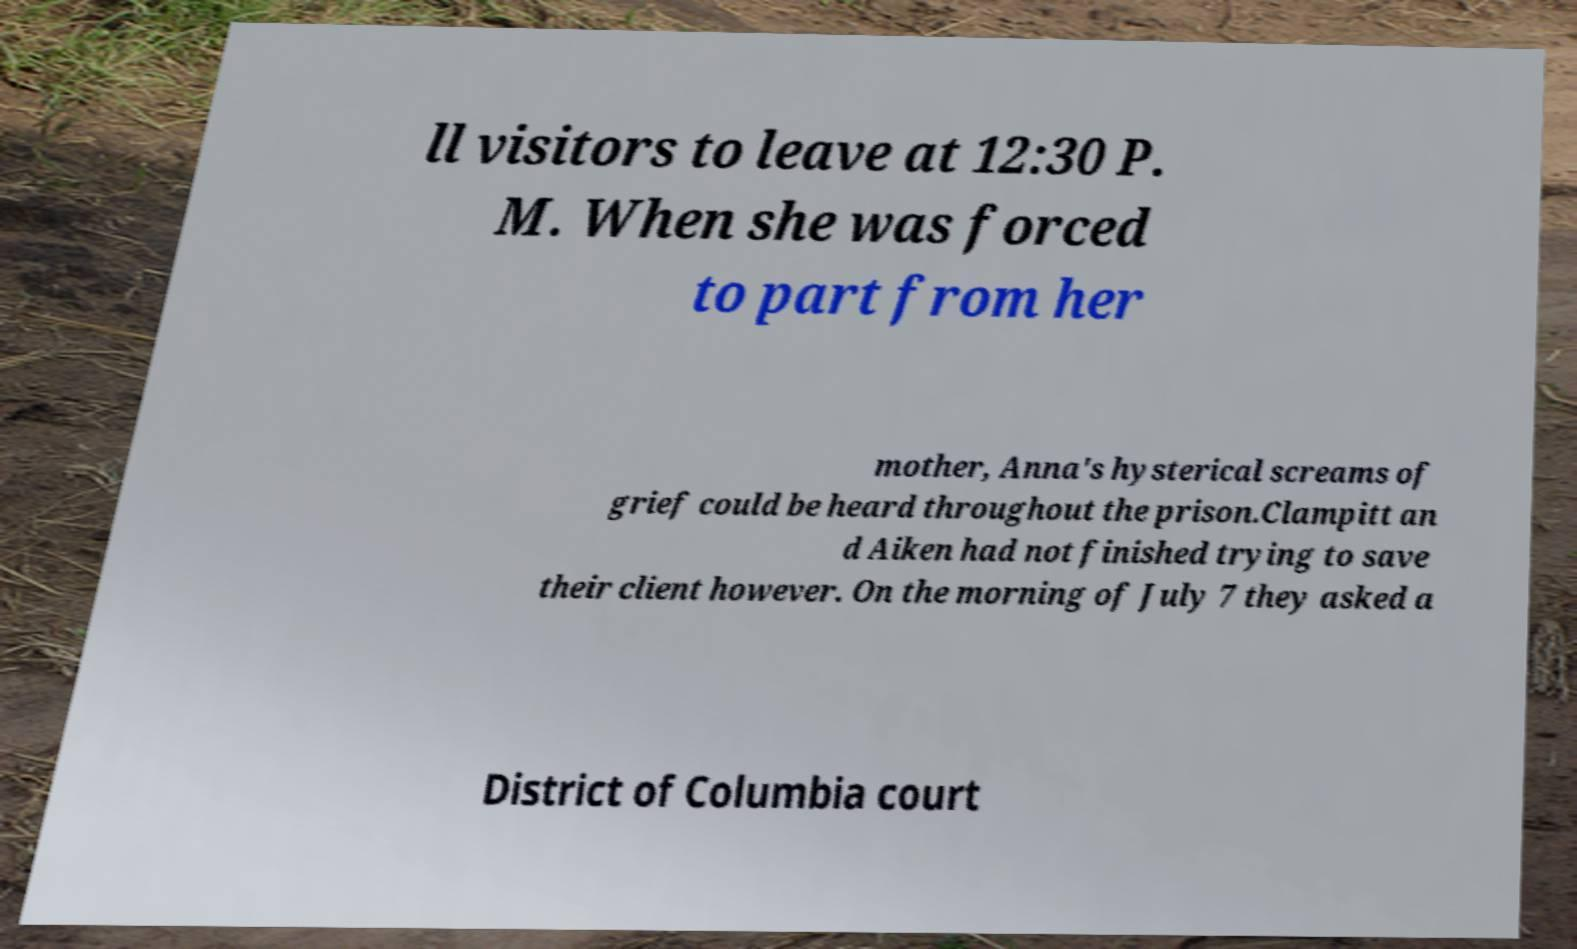Please read and relay the text visible in this image. What does it say? ll visitors to leave at 12:30 P. M. When she was forced to part from her mother, Anna's hysterical screams of grief could be heard throughout the prison.Clampitt an d Aiken had not finished trying to save their client however. On the morning of July 7 they asked a District of Columbia court 